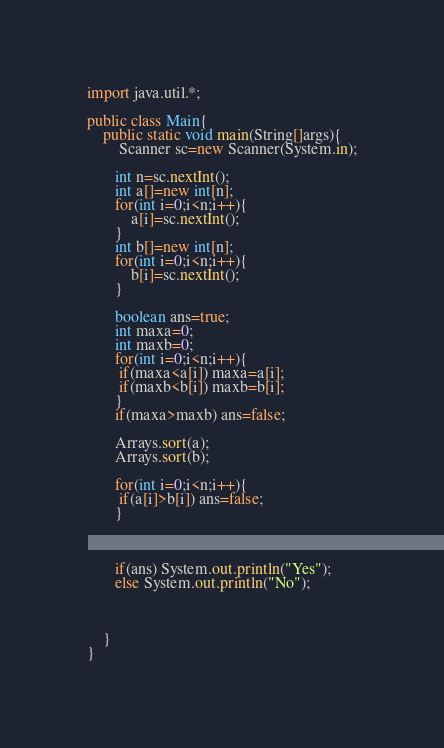Convert code to text. <code><loc_0><loc_0><loc_500><loc_500><_Java_>
import java.util.*;

public class Main{
    public static void main(String[]args){
        Scanner sc=new Scanner(System.in);

       int n=sc.nextInt();
       int a[]=new int[n];
       for(int i=0;i<n;i++){
           a[i]=sc.nextInt();
       }
       int b[]=new int[n];
       for(int i=0;i<n;i++){
           b[i]=sc.nextInt();
       }

       boolean ans=true;
       int maxa=0;
       int maxb=0;
       for(int i=0;i<n;i++){
        if(maxa<a[i]) maxa=a[i];
        if(maxb<b[i]) maxb=b[i];
       }
       if(maxa>maxb) ans=false;

       Arrays.sort(a);
       Arrays.sort(b);

       for(int i=0;i<n;i++){
        if(a[i]>b[i]) ans=false;
       }
       
    

       if(ans) System.out.println("Yes");
       else System.out.println("No");


       
    }
}
</code> 